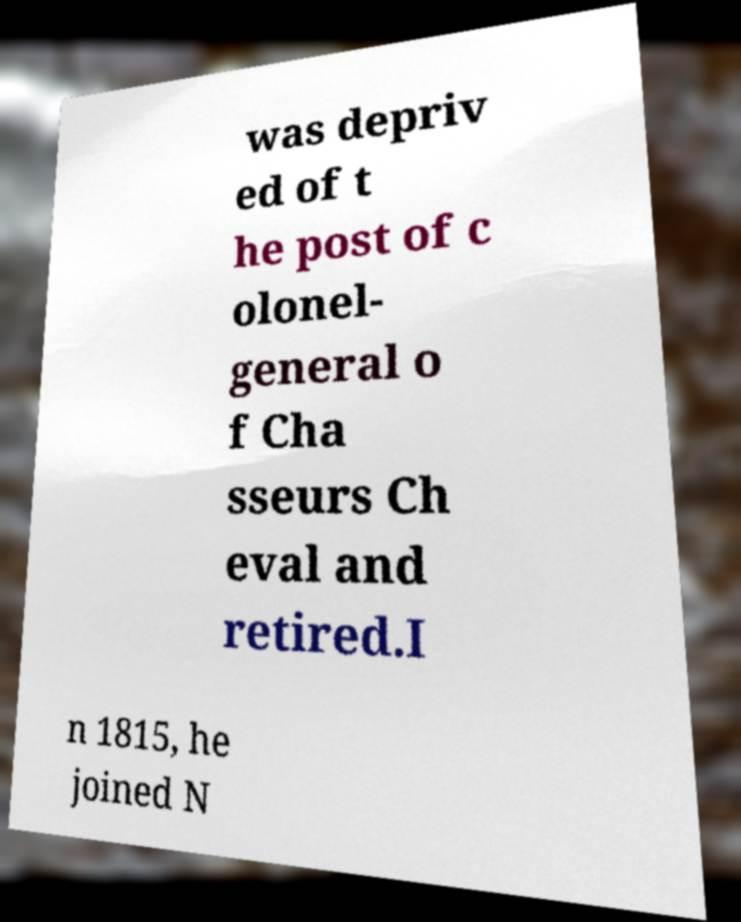Can you read and provide the text displayed in the image?This photo seems to have some interesting text. Can you extract and type it out for me? was depriv ed of t he post of c olonel- general o f Cha sseurs Ch eval and retired.I n 1815, he joined N 